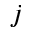<formula> <loc_0><loc_0><loc_500><loc_500>j</formula> 